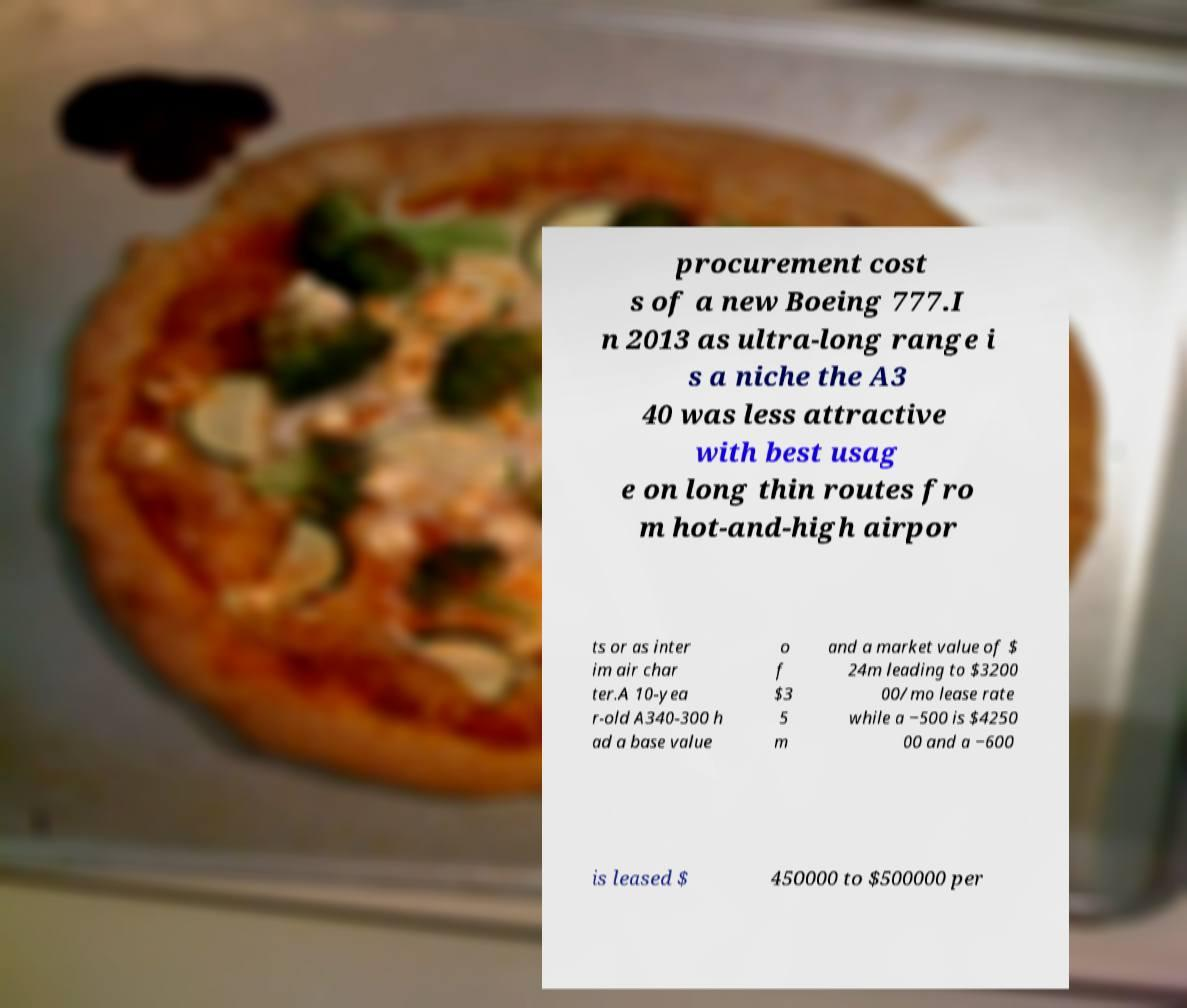Could you extract and type out the text from this image? procurement cost s of a new Boeing 777.I n 2013 as ultra-long range i s a niche the A3 40 was less attractive with best usag e on long thin routes fro m hot-and-high airpor ts or as inter im air char ter.A 10-yea r-old A340-300 h ad a base value o f $3 5 m and a market value of $ 24m leading to $3200 00/mo lease rate while a −500 is $4250 00 and a −600 is leased $ 450000 to $500000 per 